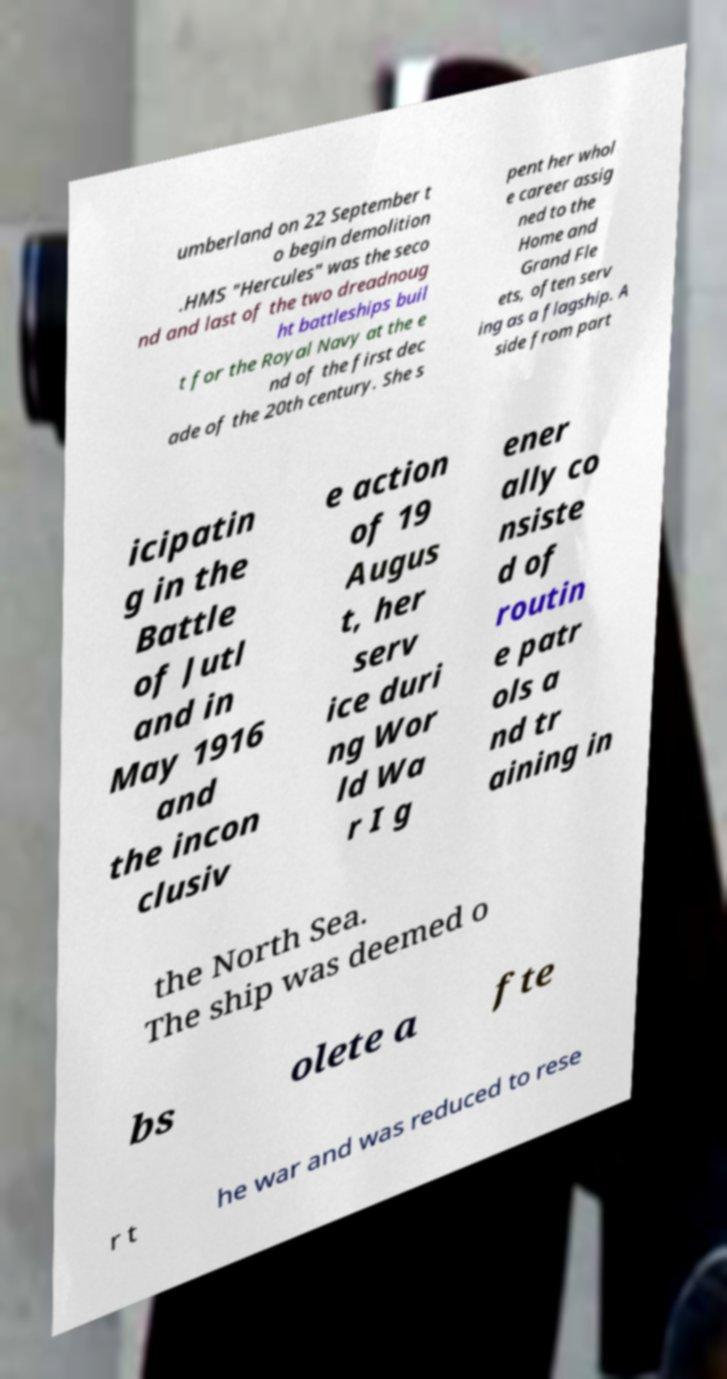Can you accurately transcribe the text from the provided image for me? umberland on 22 September t o begin demolition .HMS "Hercules" was the seco nd and last of the two dreadnoug ht battleships buil t for the Royal Navy at the e nd of the first dec ade of the 20th century. She s pent her whol e career assig ned to the Home and Grand Fle ets, often serv ing as a flagship. A side from part icipatin g in the Battle of Jutl and in May 1916 and the incon clusiv e action of 19 Augus t, her serv ice duri ng Wor ld Wa r I g ener ally co nsiste d of routin e patr ols a nd tr aining in the North Sea. The ship was deemed o bs olete a fte r t he war and was reduced to rese 